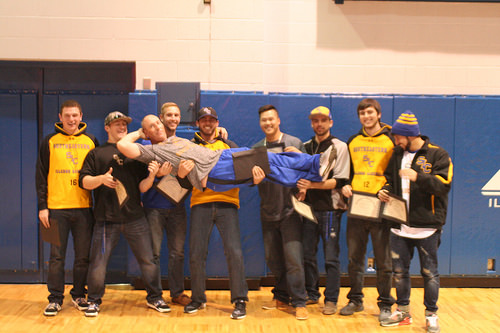<image>
Can you confirm if the man is to the left of the man? Yes. From this viewpoint, the man is positioned to the left side relative to the man. 